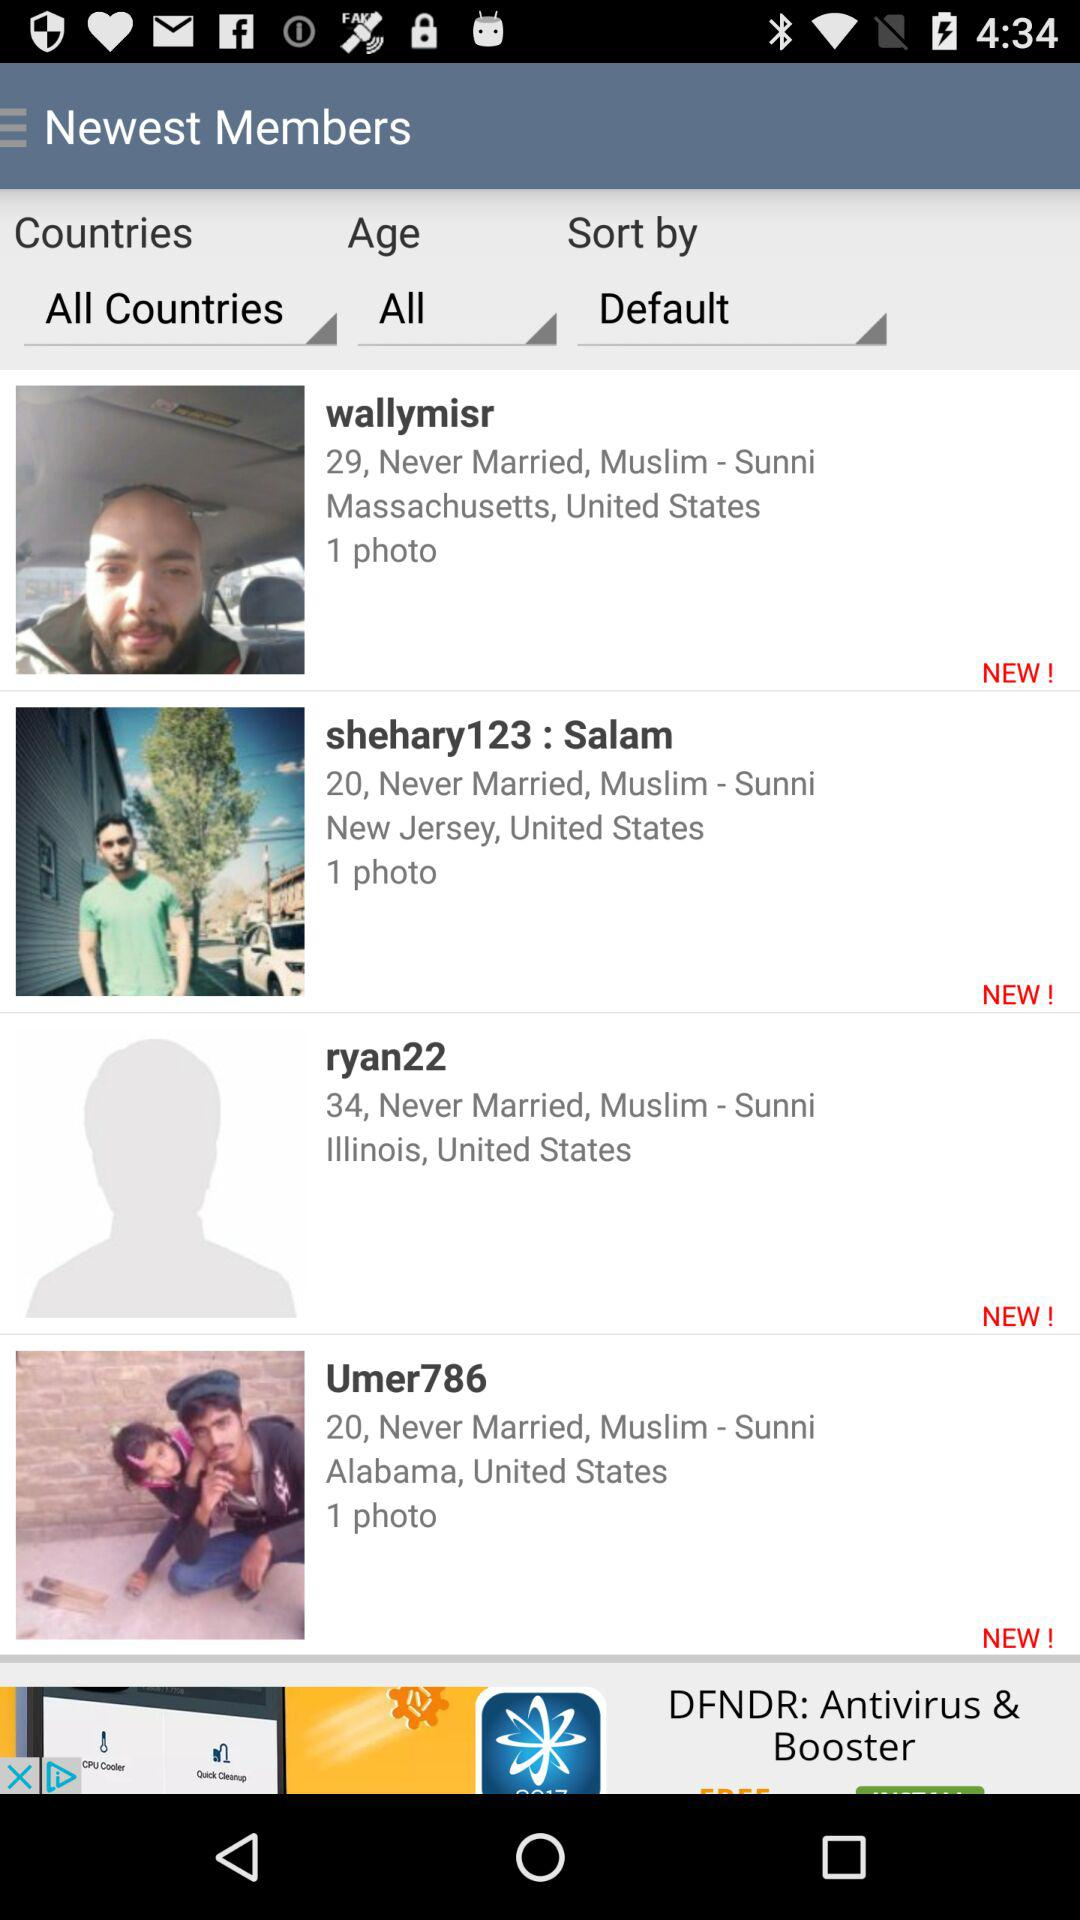What is the age of "wallymisr"? The age is 29. 